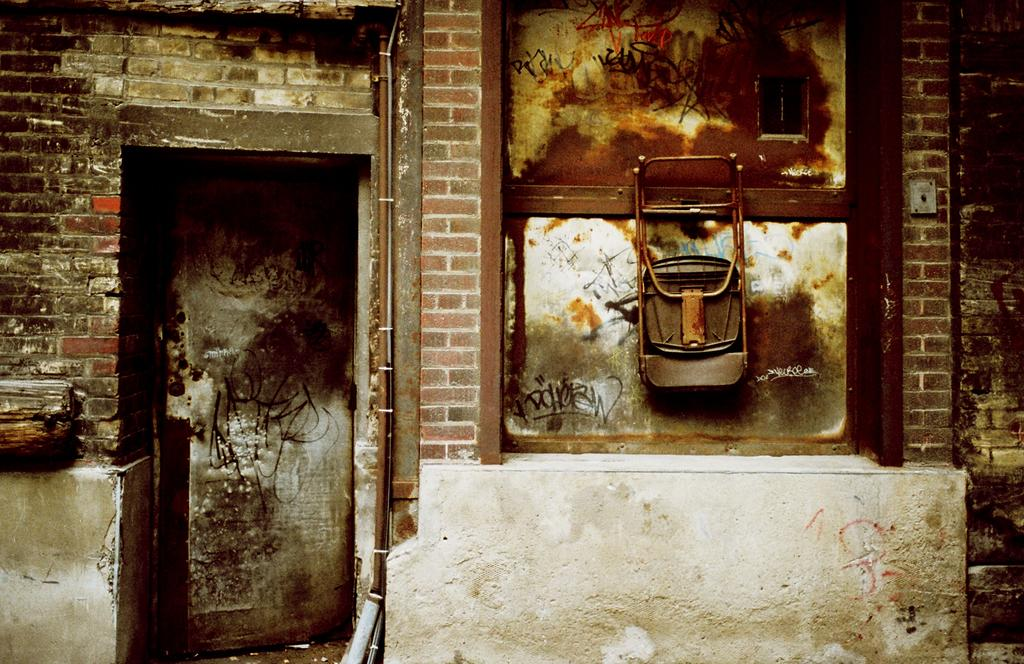What type of structure is visible in the image? There is a building in the image. What material is the building made of? The building is made up of bricks. Can you describe the color of the wall in the image? There is a white and brown wall in the image. What architectural features can be seen in the image? There is a window and a door in the image. What is attached to the window in the image? There is a metal object hanged to the window. What type of feast is being prepared in the image? There is no indication of a feast being prepared in the image; it primarily features a building with a window and a door. What is the nature of the love depicted in the image? There is no depiction of love in the image; it focuses on a building and its architectural features. 